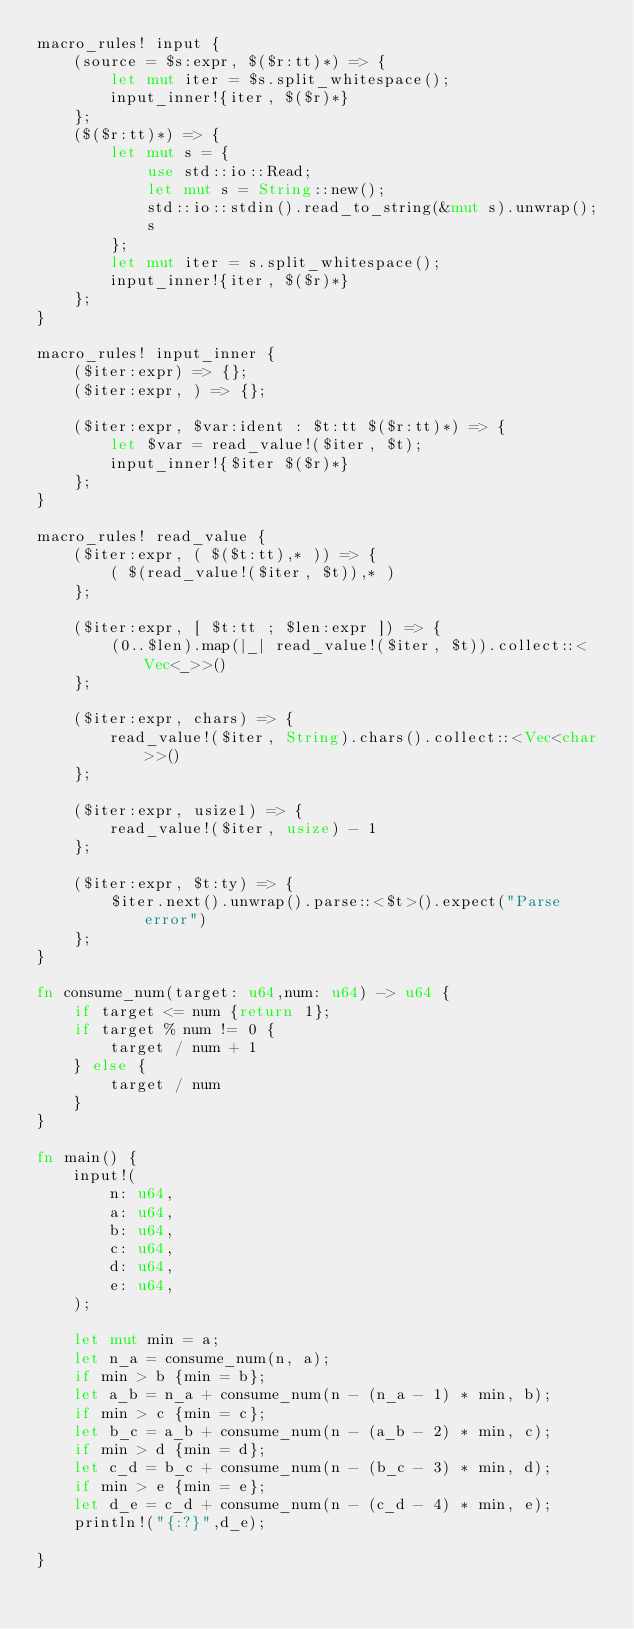<code> <loc_0><loc_0><loc_500><loc_500><_Rust_>macro_rules! input {
    (source = $s:expr, $($r:tt)*) => {
        let mut iter = $s.split_whitespace();
        input_inner!{iter, $($r)*}
    };
    ($($r:tt)*) => {
        let mut s = {
            use std::io::Read;
            let mut s = String::new();
            std::io::stdin().read_to_string(&mut s).unwrap();
            s
        };
        let mut iter = s.split_whitespace();
        input_inner!{iter, $($r)*}
    };
}

macro_rules! input_inner {
    ($iter:expr) => {};
    ($iter:expr, ) => {};

    ($iter:expr, $var:ident : $t:tt $($r:tt)*) => {
        let $var = read_value!($iter, $t);
        input_inner!{$iter $($r)*}
    };
}

macro_rules! read_value {
    ($iter:expr, ( $($t:tt),* )) => {
        ( $(read_value!($iter, $t)),* )
    };

    ($iter:expr, [ $t:tt ; $len:expr ]) => {
        (0..$len).map(|_| read_value!($iter, $t)).collect::<Vec<_>>()
    };

    ($iter:expr, chars) => {
        read_value!($iter, String).chars().collect::<Vec<char>>()
    };

    ($iter:expr, usize1) => {
        read_value!($iter, usize) - 1
    };

    ($iter:expr, $t:ty) => {
        $iter.next().unwrap().parse::<$t>().expect("Parse error")
    };
}

fn consume_num(target: u64,num: u64) -> u64 {
    if target <= num {return 1};
    if target % num != 0 {
        target / num + 1
    } else {
        target / num
    }
}

fn main() {
    input!(
        n: u64,
        a: u64,
        b: u64,
        c: u64,
        d: u64,
        e: u64,
    );

    let mut min = a;
    let n_a = consume_num(n, a); 
    if min > b {min = b};
    let a_b = n_a + consume_num(n - (n_a - 1) * min, b); 
    if min > c {min = c};
    let b_c = a_b + consume_num(n - (a_b - 2) * min, c);
    if min > d {min = d}; 
    let c_d = b_c + consume_num(n - (b_c - 3) * min, d);
    if min > e {min = e}; 
    let d_e = c_d + consume_num(n - (c_d - 4) * min, e); 
    println!("{:?}",d_e);

}
</code> 